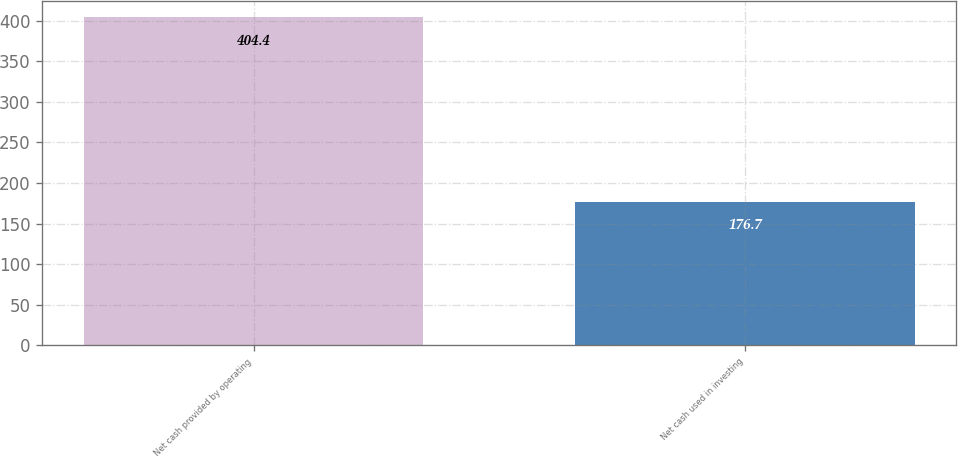Convert chart to OTSL. <chart><loc_0><loc_0><loc_500><loc_500><bar_chart><fcel>Net cash provided by operating<fcel>Net cash used in investing<nl><fcel>404.4<fcel>176.7<nl></chart> 